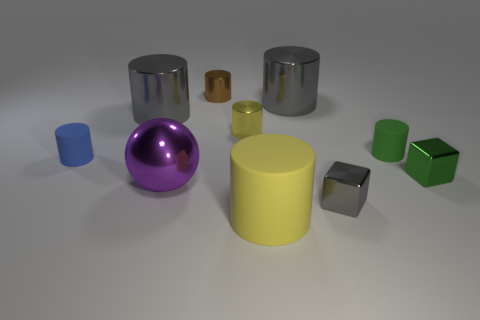Subtract all metallic cylinders. How many cylinders are left? 3 Subtract 4 cylinders. How many cylinders are left? 3 Subtract all gray spheres. How many yellow cylinders are left? 2 Subtract all brown cylinders. How many cylinders are left? 6 Subtract all brown cylinders. Subtract all yellow cubes. How many cylinders are left? 6 Subtract 1 green cylinders. How many objects are left? 9 Subtract all blocks. How many objects are left? 8 Subtract all tiny purple matte things. Subtract all green cubes. How many objects are left? 9 Add 3 blue rubber things. How many blue rubber things are left? 4 Add 7 small metallic cylinders. How many small metallic cylinders exist? 9 